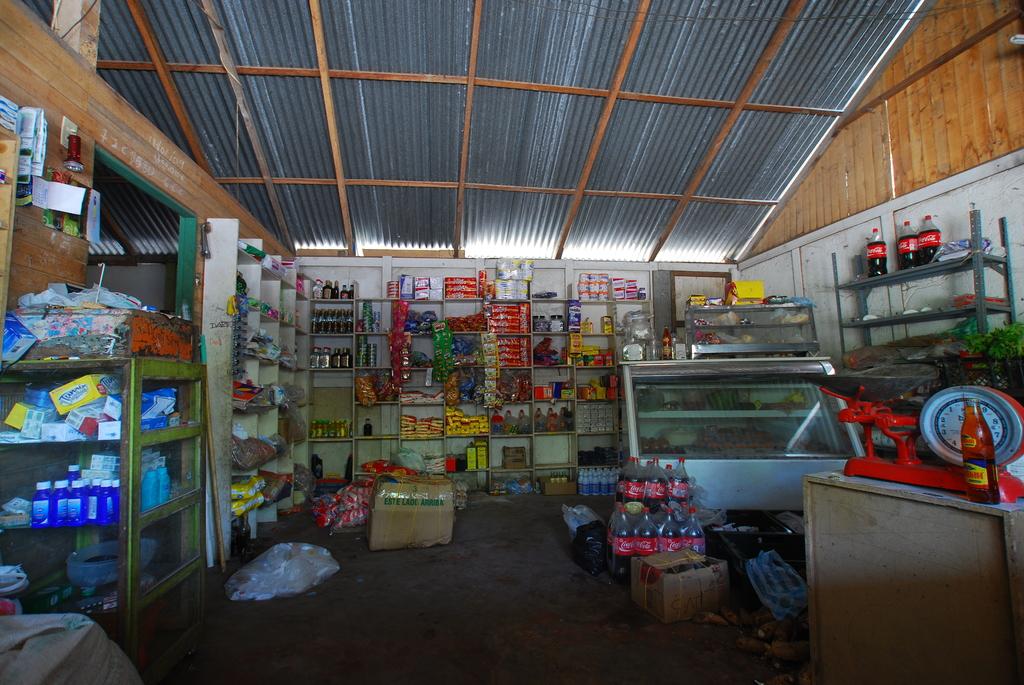What is the brand of the soda on the ground?
Make the answer very short. Coca cola. 